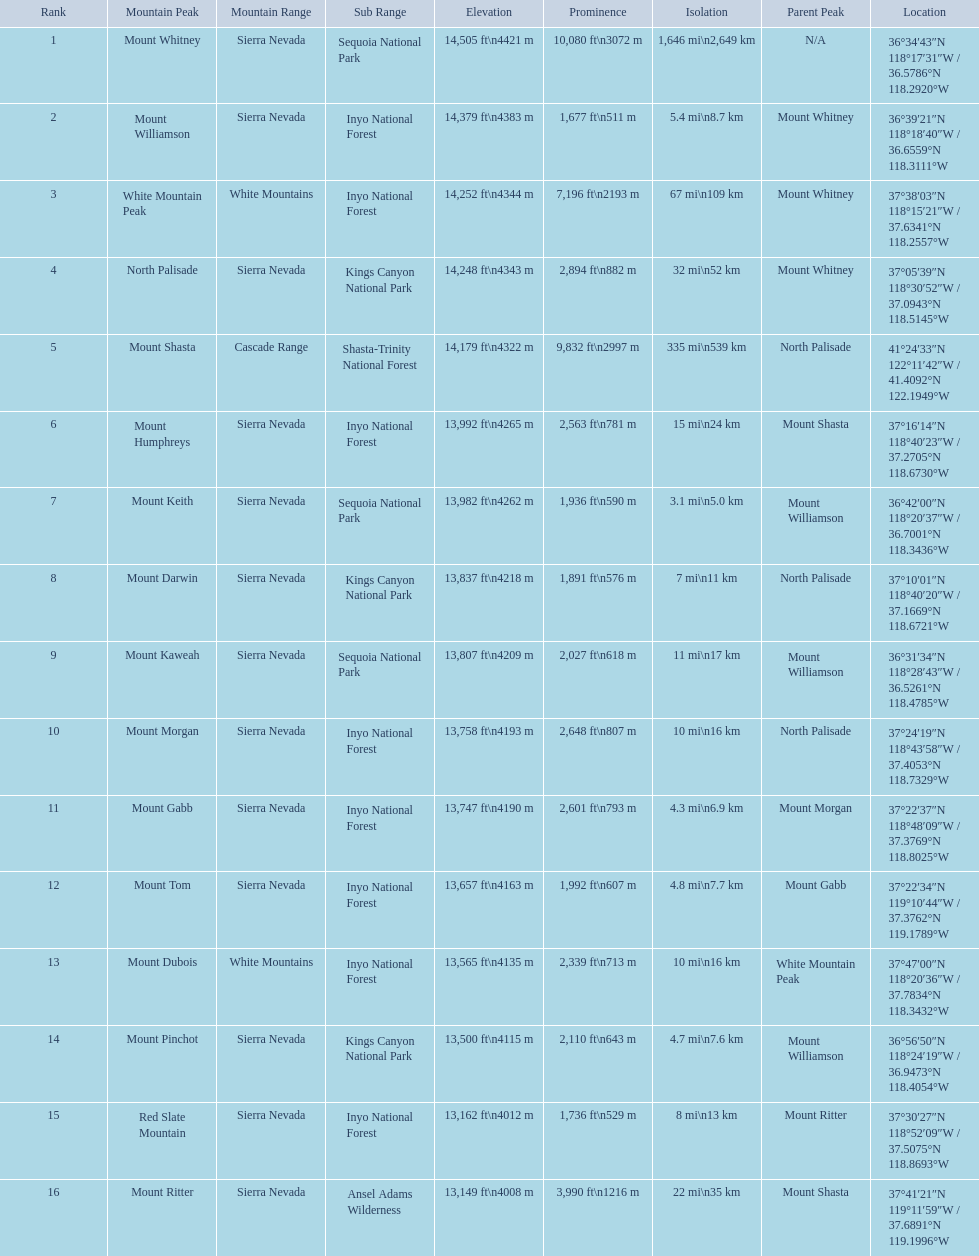Which are the mountain peaks? Mount Whitney, Mount Williamson, White Mountain Peak, North Palisade, Mount Shasta, Mount Humphreys, Mount Keith, Mount Darwin, Mount Kaweah, Mount Morgan, Mount Gabb, Mount Tom, Mount Dubois, Mount Pinchot, Red Slate Mountain, Mount Ritter. Of these, which is in the cascade range? Mount Shasta. 